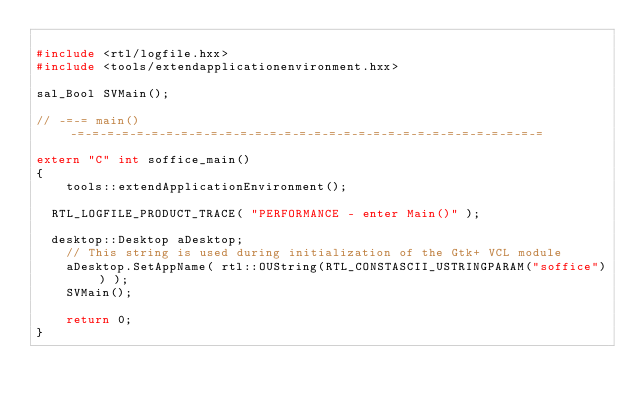<code> <loc_0><loc_0><loc_500><loc_500><_C++_>
#include <rtl/logfile.hxx>
#include <tools/extendapplicationenvironment.hxx>

sal_Bool SVMain();

// -=-= main() -=-=-=-=-=-=-=-=-=-=-=-=-=-=-=-=-=-=-=-=-=-=-=-=-=-=-=-=-=-=-=-=

extern "C" int soffice_main()
{
    tools::extendApplicationEnvironment();

	RTL_LOGFILE_PRODUCT_TRACE( "PERFORMANCE - enter Main()" );

	desktop::Desktop aDesktop;
    // This string is used during initialization of the Gtk+ VCL module
    aDesktop.SetAppName( rtl::OUString(RTL_CONSTASCII_USTRINGPARAM("soffice")) );
    SVMain();

    return 0;
}
</code> 